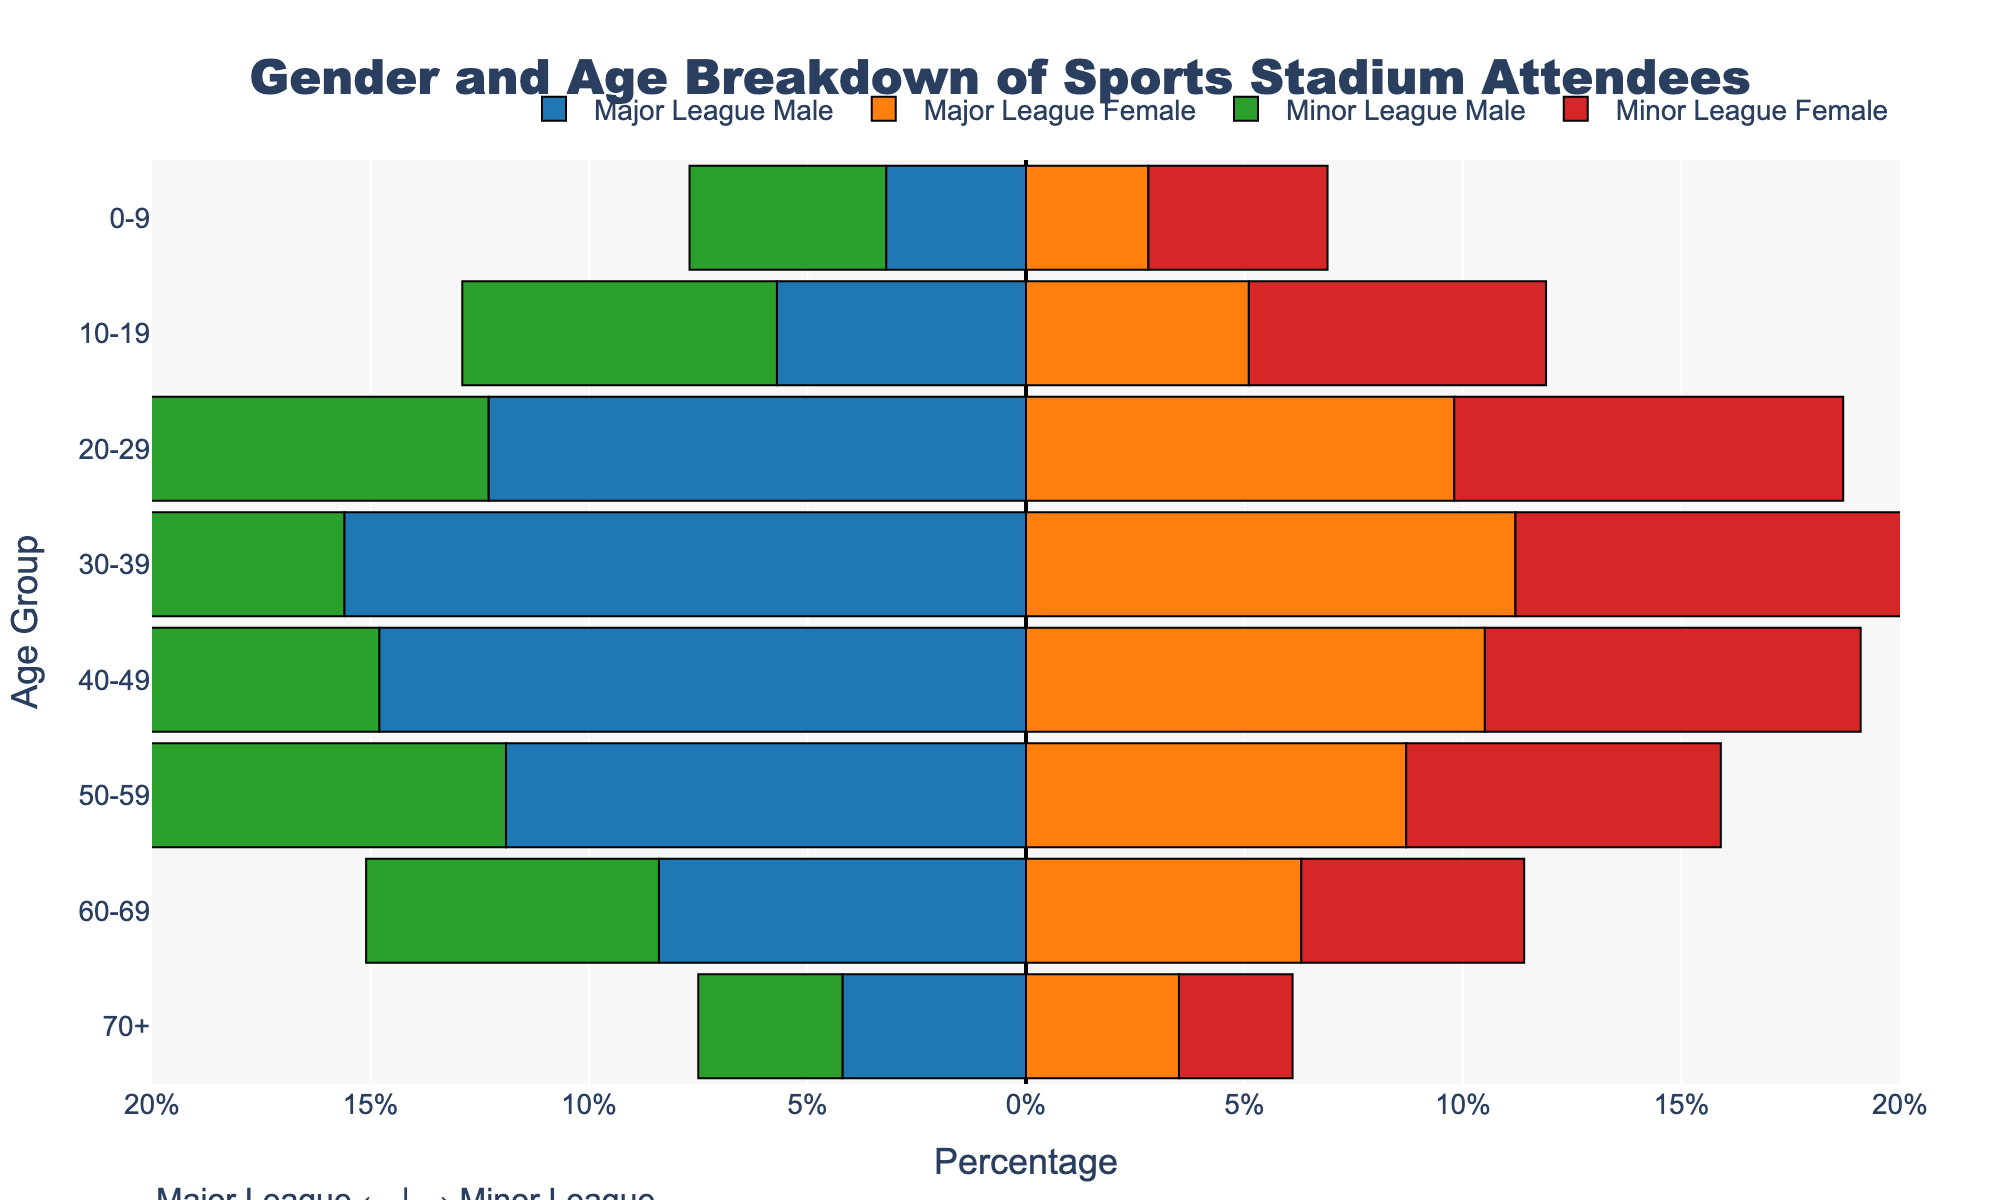What are the four colored bars representing in the plot? The plot has four types of bars differentiated by colors: blue for Major League Males, orange for Major League Females, green for Minor League Males, and red for Minor League Females.
Answer: Major League Males, Major League Females, Minor League Males, Minor League Females Which age group has the highest percentage of attendance in Major League games for males? By looking at the plot, the age group 30-39 has the highest percentage for Major League Males, indicated by the longest blue bar extending to the left.
Answer: 30-39 How does the attendance of females in the 20-29 age group compare between Major League and Minor League games? For the 20-29 age group, the orange bar (Major League Females) is longer than the red bar (Minor League Females). This means attendance is higher for Major League games.
Answer: Higher in Major League What is the total percentage of Major League attendees aged 50-59? To find the total, add the percentages in the 50-59 age group for both males and females: 11.9% (males) + 8.7% (females) = 20.6%.
Answer: 20.6% Which age group has the lowest percentage of Minor League Female attendees? The age group 70+ has the shortest red bar, indicating the lowest percentage of Minor League Female attendees.
Answer: 70+ Are there more attendees aged 0-9 in Major League or Minor League games? Comparing the lengths of both bars for the 0-9 age group, the bars for Minor League (green and red) are longer than those for Major League (blue and orange).
Answer: Minor League Is there any age group where males attend Minor League games more than Major League games? The green bars for Minor League Males are longer than the blue bars for Major League Males in the 0-9, 10-19, and 60-69 age groups.
Answer: Yes, 0-9, 10-19, and 60-69 Which gender has a higher total percentage attendance in Major League games? By adding up the percentages for each age group and gender in Major League games, males have a higher total percentage than females.
Answer: Males What percentage of attendees are in the 40-49 age group for Minor League Males? By looking at the length of the green bar for the 40-49 age group, it is 11.3%.
Answer: 11.3% Which league (Major or Minor) generally has higher attendance for the 20-29 age group? Summing up both genders in the 20-29 age group, Major League (12.3% males + 9.8% females) = 22.1%, while Minor League (10.5% males + 8.9% females) = 19.4%. The total is higher for Major League.
Answer: Major League 